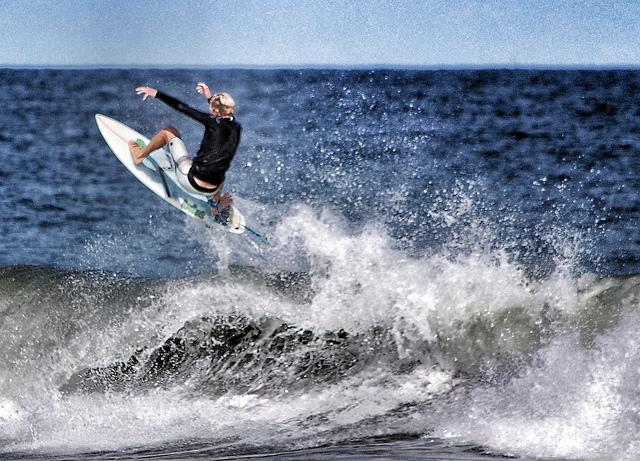Is the sun out?
Be succinct. Yes. What is the person riding?
Keep it brief. Surfboard. What is this person doing?
Quick response, please. Surfing. 